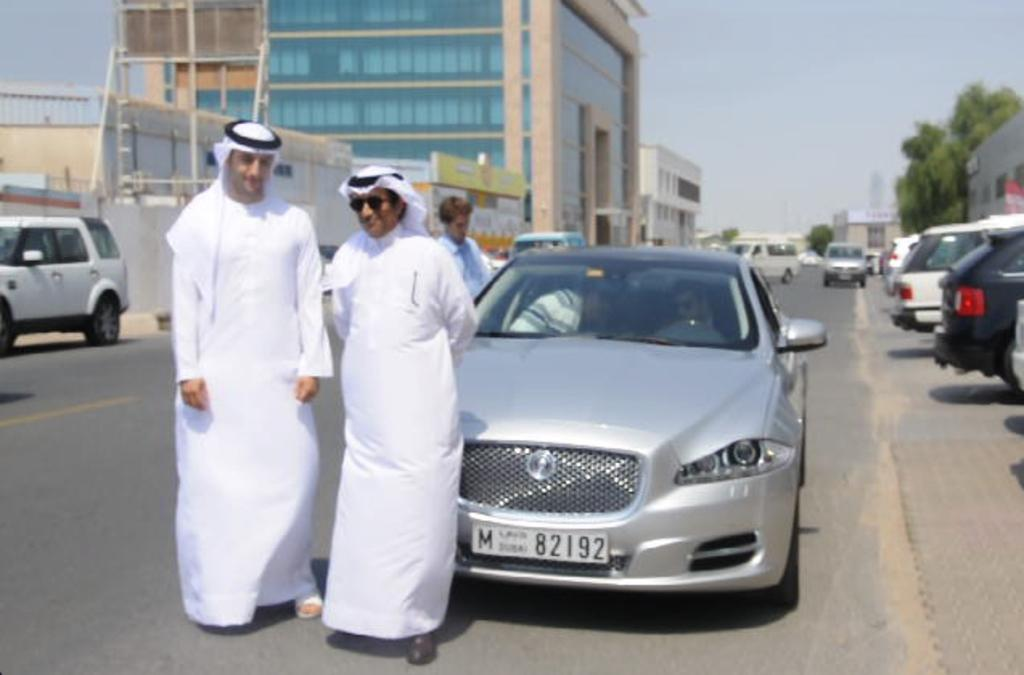What can be seen in the image involving people? There are people standing in the image. What else is present in the image besides people? There are vehicles on the road and buildings visible in the background of the image. What type of vegetation can be seen in the background? There are trees in the background of the image. What is visible at the top of the image? The sky is visible at the top of the image. Is there a fold in the sky in the image? There is no fold in the sky in the image; the sky is a continuous, flat surface. Are the people in the image crying? There is no indication in the image that the people are crying; their facial expressions are not visible. 